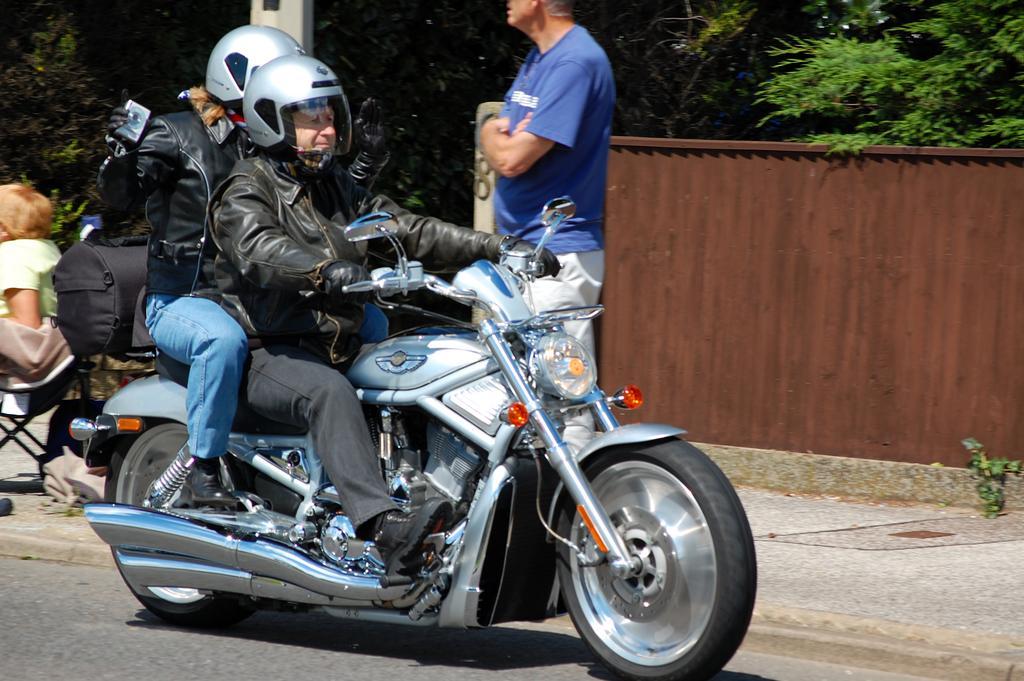How would you summarize this image in a sentence or two? In this image i can see two persons riding on a bike wearing a black color jacket and a helmet. On the road side we have a man who is wearing blue color t-shirt and a person who is sitting on a chair. On the right side of the image we have a tree. 